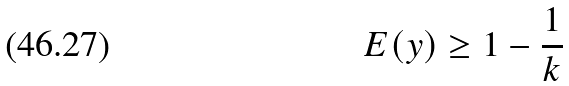Convert formula to latex. <formula><loc_0><loc_0><loc_500><loc_500>E ( y ) \geq 1 - \frac { 1 } { k }</formula> 